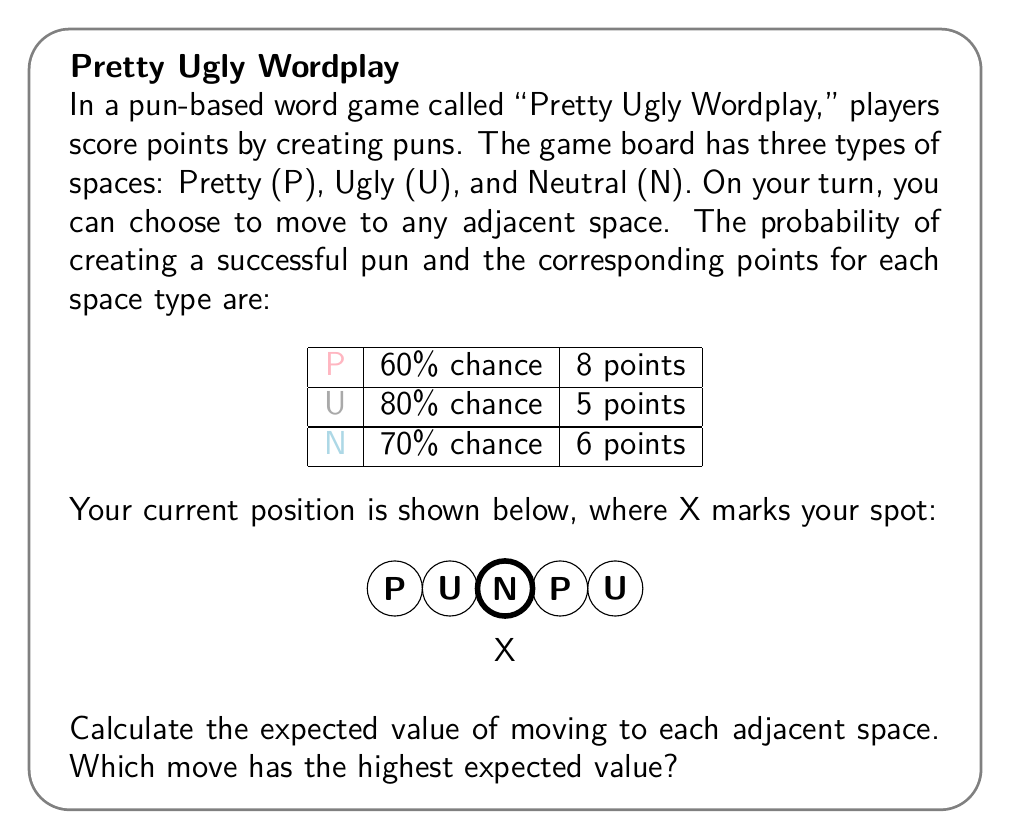Can you answer this question? Let's calculate the expected value for each possible move:

1. Moving left to the Neutral (N) space:
   $$ E(N) = 0.70 \times 6 + 0.30 \times 0 = 4.2 $$

2. Moving right to the Pretty (P) space:
   $$ E(P) = 0.60 \times 8 + 0.40 \times 0 = 4.8 $$

To determine which move has the highest expected value, we compare the results:

$$ E(P) = 4.8 > E(N) = 4.2 $$

Therefore, moving right to the Pretty (P) space has the highest expected value.

This result aligns with the "Pretty Ugly" theme of the game, as the Pretty space offers a higher potential reward despite having a lower probability of success compared to the Neutral space.
Answer: Move right (P); E(P) = 4.8 